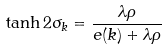Convert formula to latex. <formula><loc_0><loc_0><loc_500><loc_500>\tanh 2 \sigma _ { k } = \frac { \lambda \rho } { e ( k ) + \lambda \rho }</formula> 